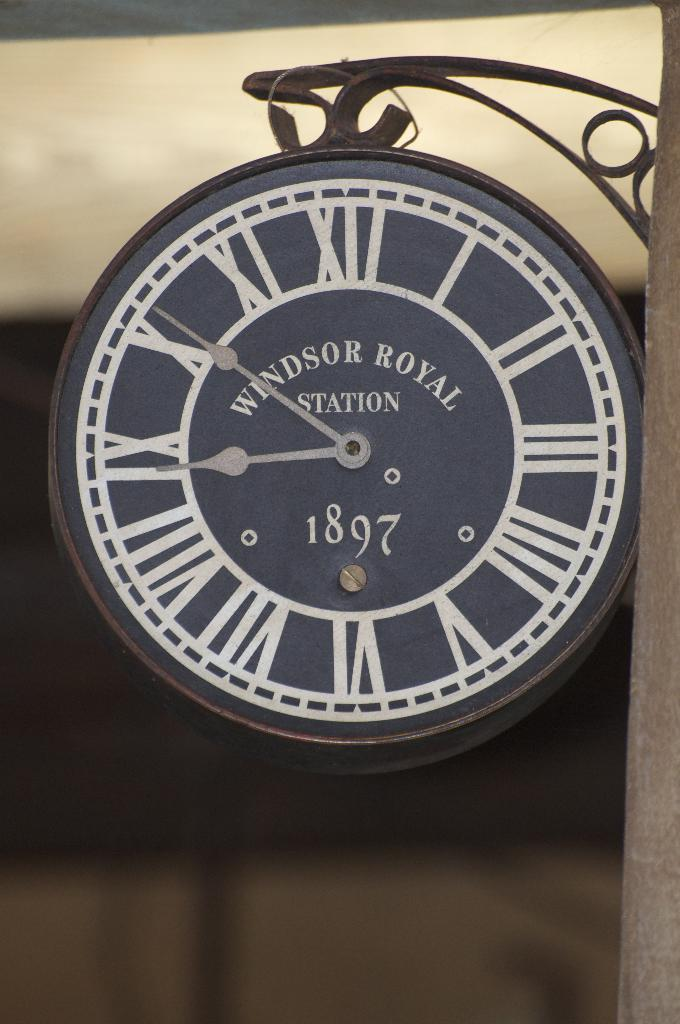<image>
Summarize the visual content of the image. A Windsor Royal Station clock shows the time of 8:51. 